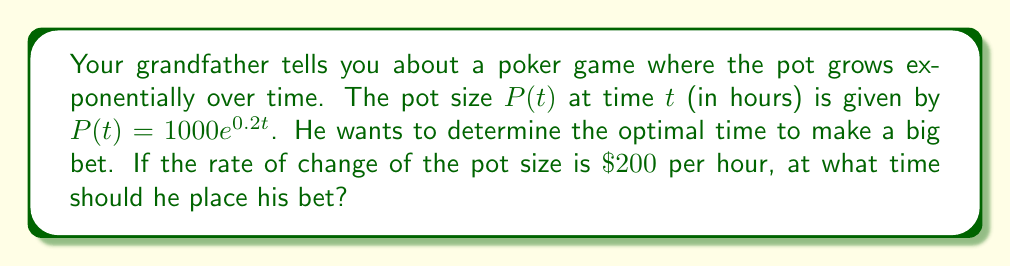Provide a solution to this math problem. Let's approach this step-by-step:

1) We're given that the pot size function is $P(t) = 1000e^{0.2t}$.

2) The rate of change of the pot size is given by the derivative of $P(t)$:

   $$\frac{dP}{dt} = 1000 \cdot 0.2e^{0.2t} = 200e^{0.2t}$$

3) We're told that the optimal time to bet is when this rate of change equals 200:

   $$200e^{0.2t} = 200$$

4) Now we can solve for $t$:

   $$e^{0.2t} = 1$$

5) Taking the natural logarithm of both sides:

   $$0.2t = \ln(1) = 0$$

6) Solving for $t$:

   $$t = \frac{0}{0.2} = 0$$

Therefore, the optimal time to place the bet is at $t = 0$, or immediately at the start of the game.
Answer: $t = 0$ hours 